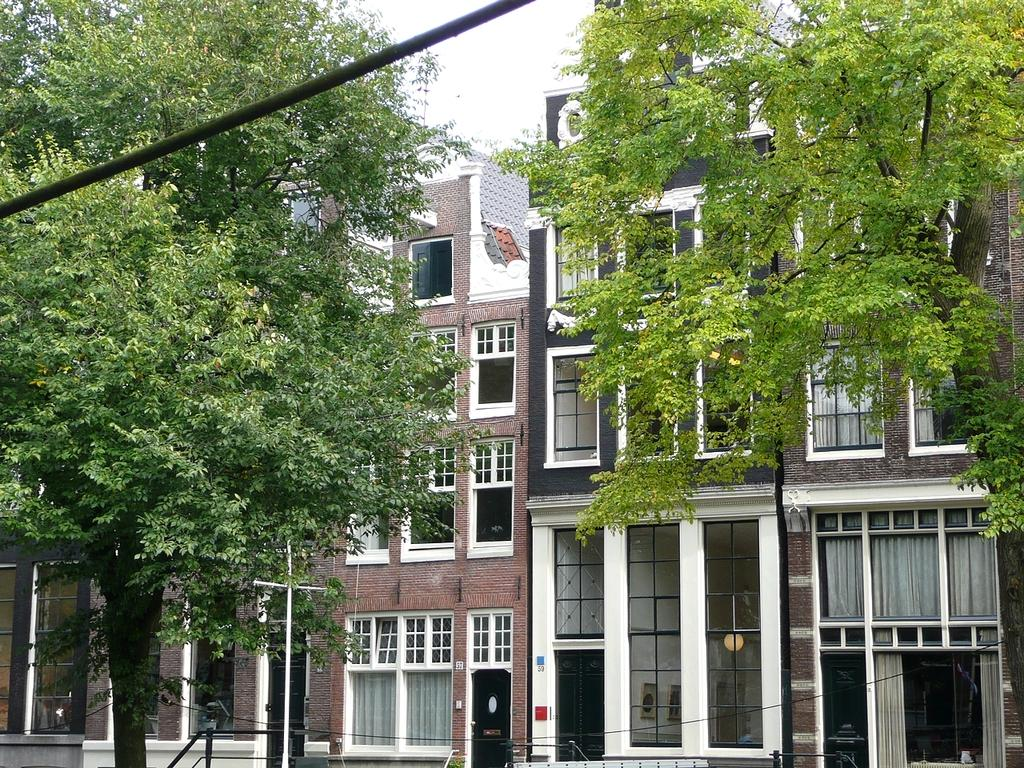What type of structures can be seen in the image? There are buildings in the image. What feature do the buildings have? The buildings have glass windows. What can be seen on the left side of the image? There are trees on the left side of the image. What can be seen on the right side of the image? There are trees on the right side of the image. Where is the metal rope located in the image? The metal rope is on the top left side of the image. What type of parent is depicted in the image? There is no parent present in the image; it features buildings, trees, and a metal rope. How many spiders are visible on the metal rope in the image? There are no spiders visible on the metal rope in the image. 